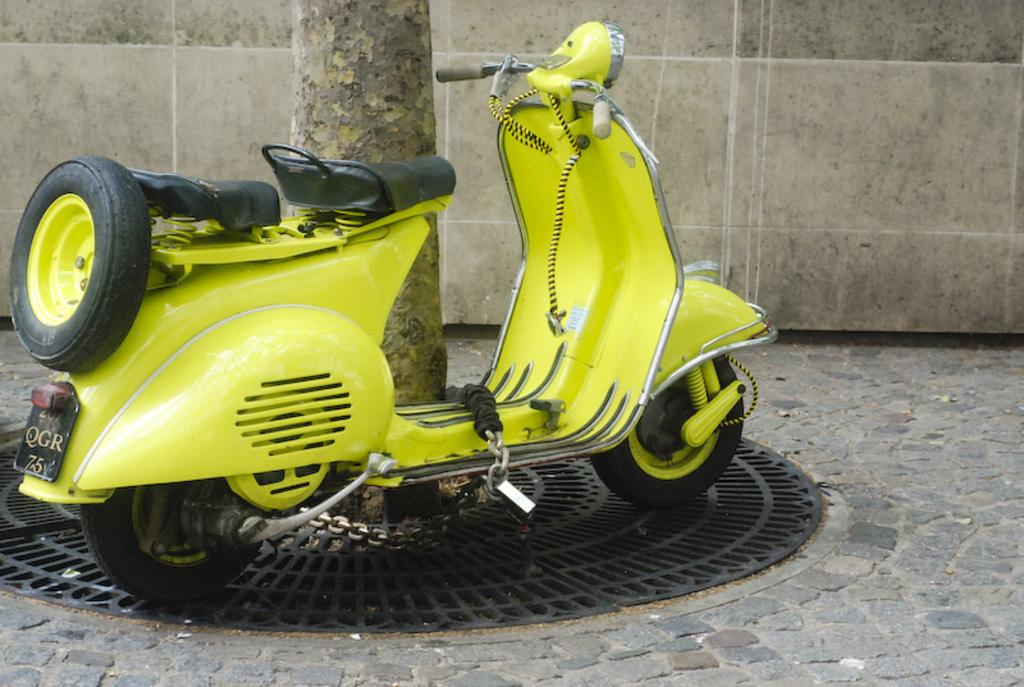What type of vehicle is in the image? The specific type of vehicle is not mentioned, but there is a vehicle present in the image. What is the metal object on the ground in the image? The facts do not specify the purpose or identity of the metal object, only that it is on the ground. What is the wall made of in the image? The facts do not specify the material of the wall, only that it is present in the image. What part of the tree is visible in the image? The trunk of the tree is visible in the image. Is there a volcanic activity visible in the image? No, there is no volcanic activity present in the image. What type of attraction can be seen in the image? There is no attraction visible in the image; the facts only mention a vehicle, a metal object, a wall, and a tree trunk. 